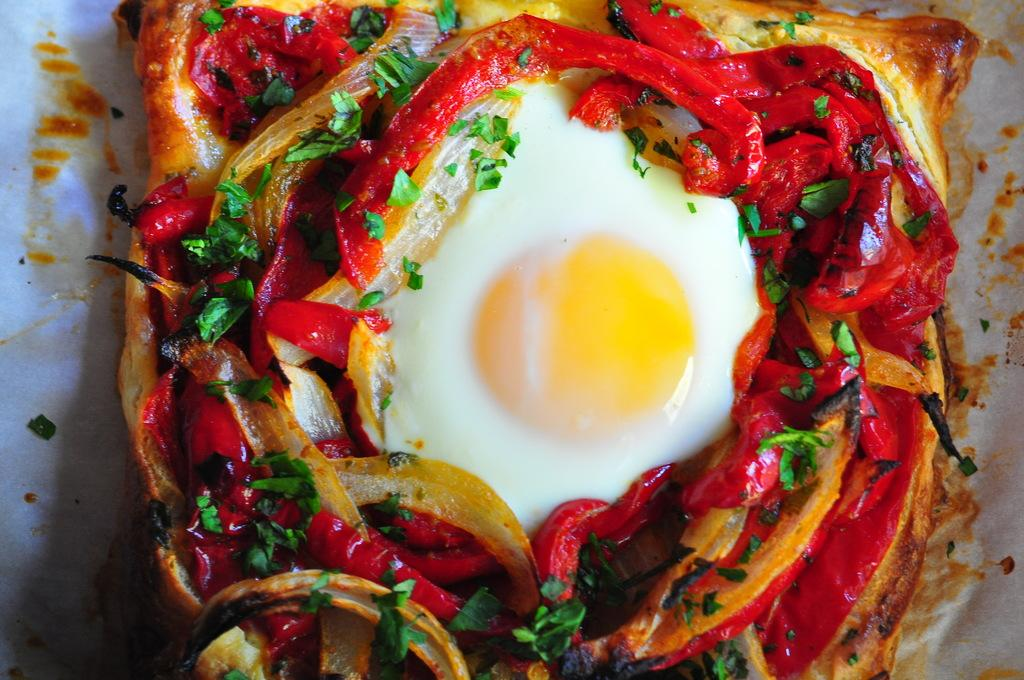What type of food can be seen in the image? There is food in the image, but the specific type cannot be determined from the facts provided. How is the food presented in the image? The food is placed on a thin paper. What ingredients are included in the food? The food contains onions, egg white, egg yolk, and coriander. How many chairs are visible in the image? There is no mention of chairs in the facts provided, so it cannot be determined if any are visible in the image. What type of canvas is used to create the food in the image? The facts provided do not mention a canvas, so it cannot be determined if one is used to create the food in the image. 